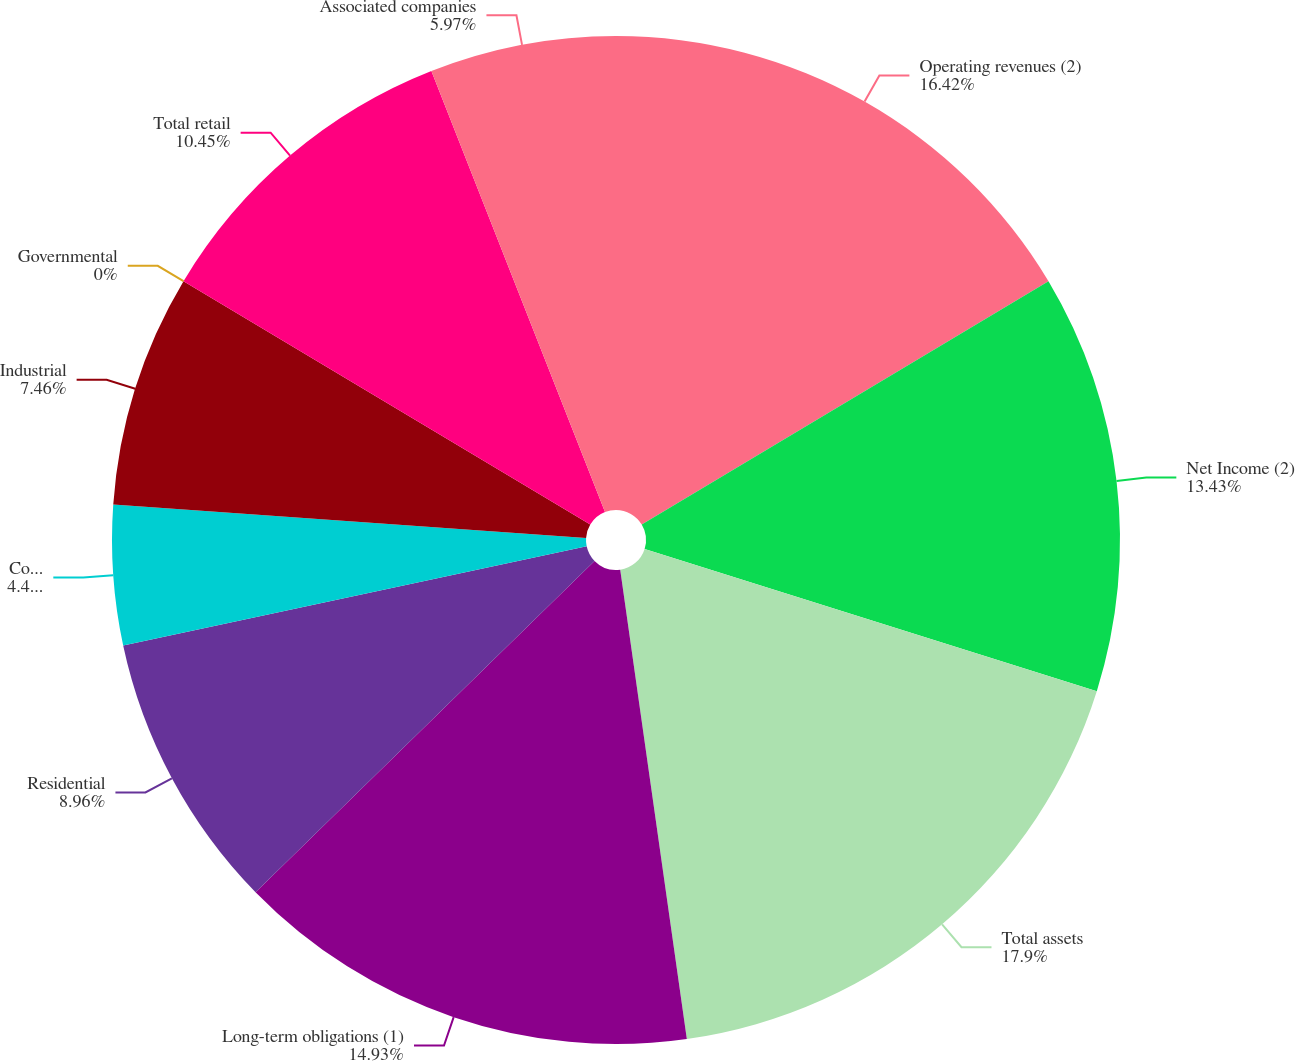Convert chart. <chart><loc_0><loc_0><loc_500><loc_500><pie_chart><fcel>Operating revenues (2)<fcel>Net Income (2)<fcel>Total assets<fcel>Long-term obligations (1)<fcel>Residential<fcel>Commercial<fcel>Industrial<fcel>Governmental<fcel>Total retail<fcel>Associated companies<nl><fcel>16.42%<fcel>13.43%<fcel>17.91%<fcel>14.93%<fcel>8.96%<fcel>4.48%<fcel>7.46%<fcel>0.0%<fcel>10.45%<fcel>5.97%<nl></chart> 